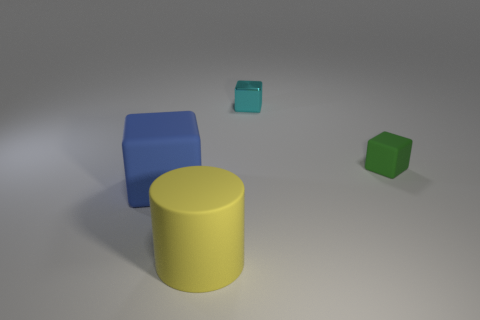What number of other things are the same size as the cyan object?
Make the answer very short. 1. What is the shape of the other thing that is the same size as the blue matte object?
Provide a short and direct response. Cylinder. Are there any rubber cylinders to the right of the yellow thing?
Make the answer very short. No. Are there any other big blue matte objects of the same shape as the blue thing?
Keep it short and to the point. No. Is the shape of the rubber object on the left side of the big rubber cylinder the same as the matte object that is right of the matte cylinder?
Your answer should be compact. Yes. Is there a purple matte ball of the same size as the yellow rubber cylinder?
Give a very brief answer. No. Are there an equal number of matte cylinders that are behind the big yellow rubber thing and small blocks in front of the big blue rubber object?
Offer a very short reply. Yes. Does the tiny block on the right side of the cyan metal object have the same material as the large object that is on the right side of the blue thing?
Your answer should be very brief. Yes. What material is the small cyan cube?
Your answer should be very brief. Metal. What number of other things are there of the same color as the rubber cylinder?
Keep it short and to the point. 0. 